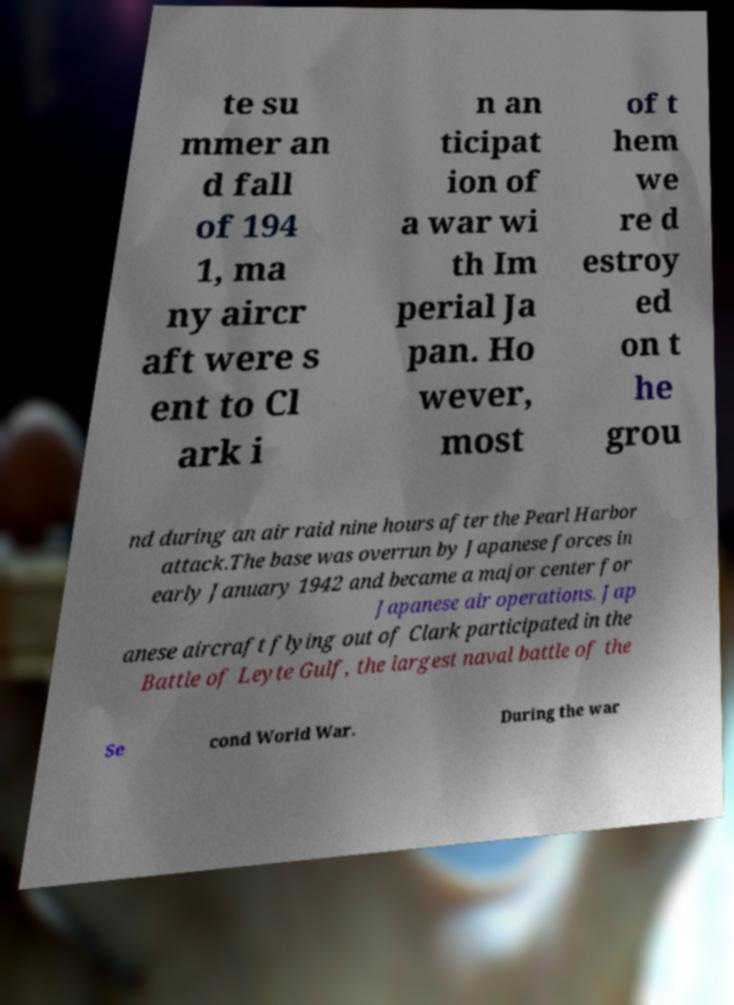Please read and relay the text visible in this image. What does it say? te su mmer an d fall of 194 1, ma ny aircr aft were s ent to Cl ark i n an ticipat ion of a war wi th Im perial Ja pan. Ho wever, most of t hem we re d estroy ed on t he grou nd during an air raid nine hours after the Pearl Harbor attack.The base was overrun by Japanese forces in early January 1942 and became a major center for Japanese air operations. Jap anese aircraft flying out of Clark participated in the Battle of Leyte Gulf, the largest naval battle of the Se cond World War. During the war 